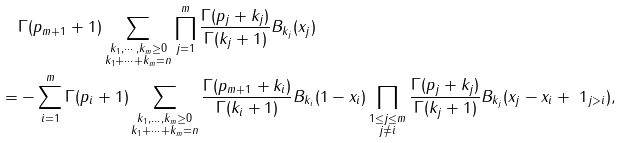<formula> <loc_0><loc_0><loc_500><loc_500>& \Gamma ( p _ { m + 1 } + 1 ) \sum _ { \substack { k _ { 1 } , \cdots , k _ { m } \geq 0 \\ k _ { 1 } + \cdots + k _ { m } = n } } \prod _ { j = 1 } ^ { m } \frac { \Gamma ( p _ { j } + k _ { j } ) } { \Gamma ( k _ { j } + 1 ) } B _ { k _ { j } } ( x _ { j } ) \\ = & - \sum _ { i = 1 } ^ { m } \Gamma ( p _ { i } + 1 ) \sum _ { \substack { k _ { 1 } , \dots , k _ { m } \geq 0 \\ k _ { 1 } + \cdots + k _ { m } = n } } \frac { \Gamma ( p _ { m + 1 } + k _ { i } ) } { \Gamma ( k _ { i } + 1 ) } B _ { k _ { i } } ( 1 - x _ { i } ) \prod _ { \substack { 1 \leq j \leq m \\ j \not = i } } \frac { \Gamma ( p _ { j } + k _ { j } ) } { \Gamma ( k _ { j } + 1 ) } B _ { k _ { j } } ( x _ { j } - x _ { i } + \ 1 _ { j > i } ) ,</formula> 